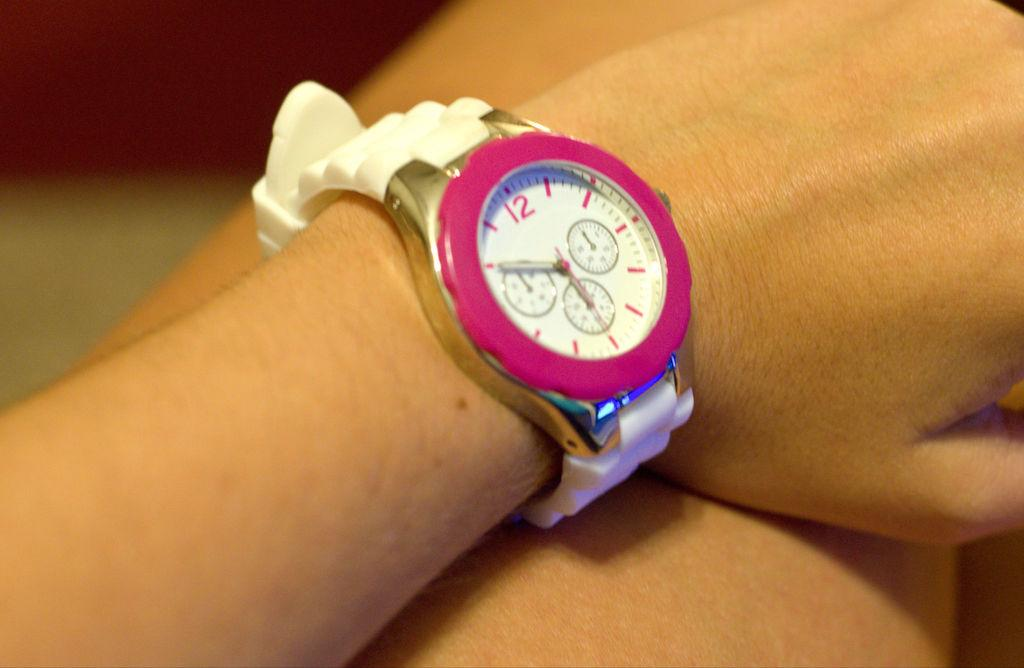<image>
Write a terse but informative summary of the picture. A pink, gold and white watch on a wrist displaying 6:50. 